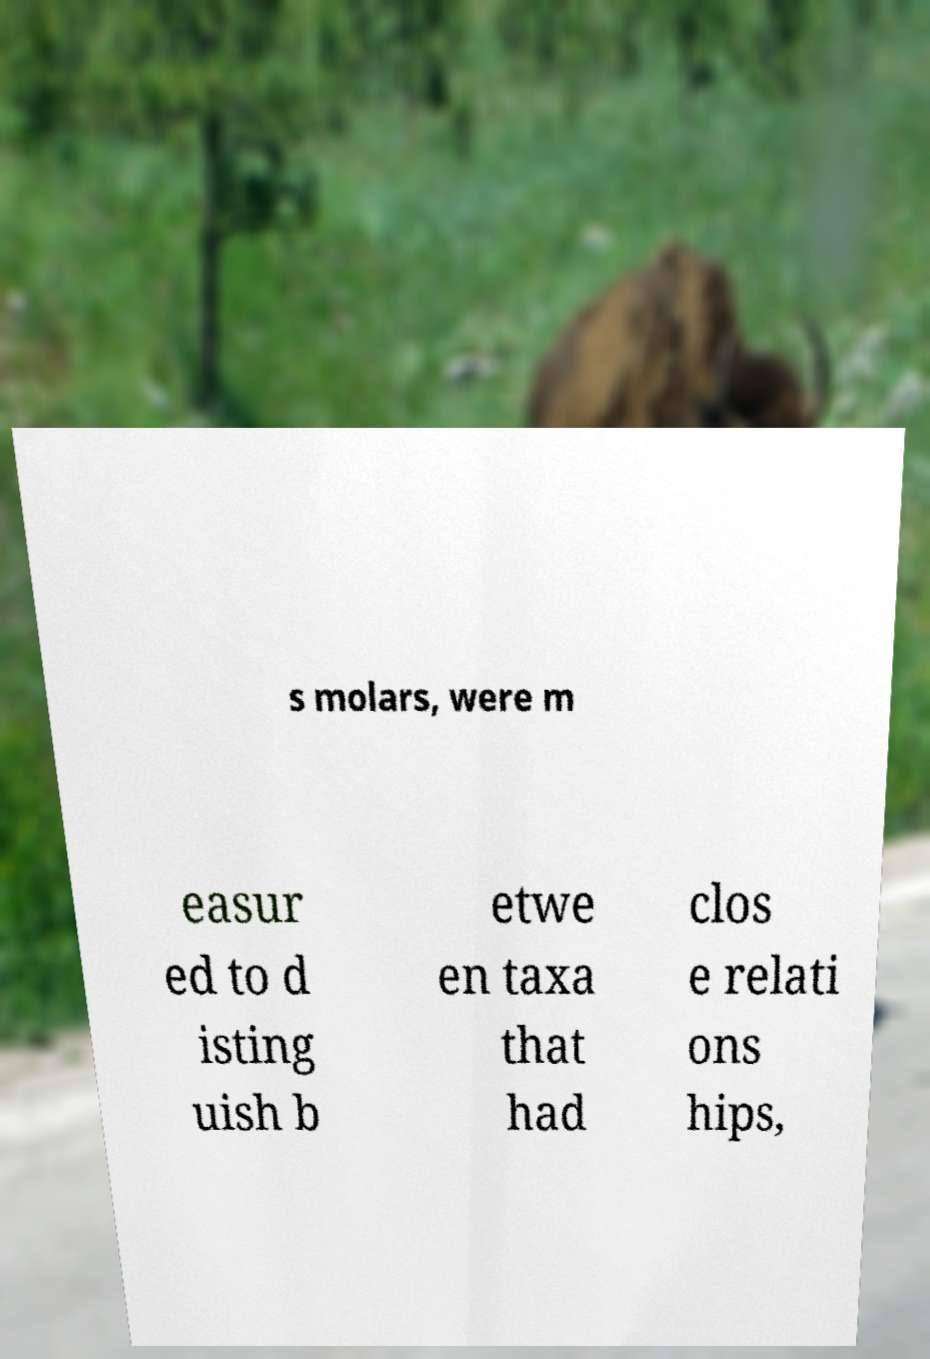For documentation purposes, I need the text within this image transcribed. Could you provide that? s molars, were m easur ed to d isting uish b etwe en taxa that had clos e relati ons hips, 